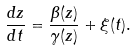<formula> <loc_0><loc_0><loc_500><loc_500>\frac { d z } { d t } = \frac { \beta ( z ) } { \gamma ( z ) } + \xi ( t ) .</formula> 